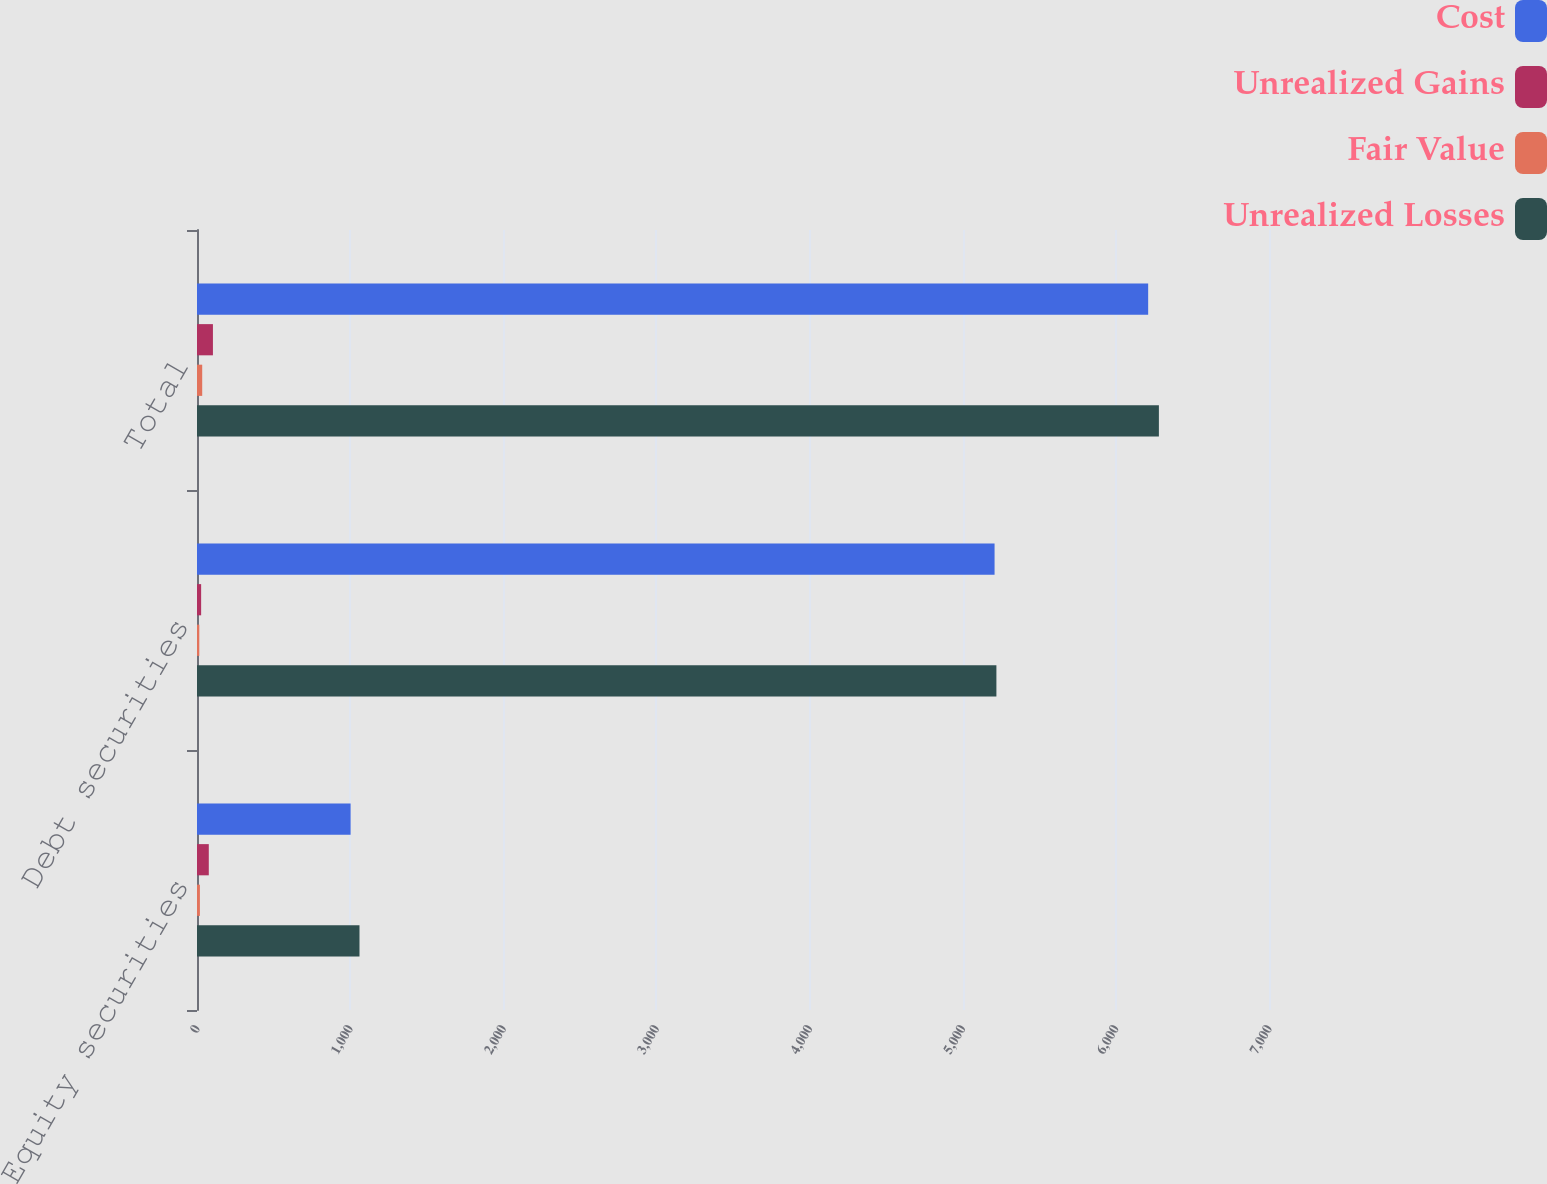Convert chart to OTSL. <chart><loc_0><loc_0><loc_500><loc_500><stacked_bar_chart><ecel><fcel>Equity securities<fcel>Debt securities<fcel>Total<nl><fcel>Cost<fcel>1003<fcel>5208<fcel>6211<nl><fcel>Unrealized Gains<fcel>77<fcel>27<fcel>104<nl><fcel>Fair Value<fcel>19<fcel>15<fcel>34<nl><fcel>Unrealized Losses<fcel>1061<fcel>5220<fcel>6281<nl></chart> 